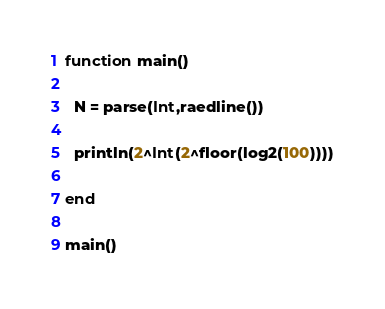Convert code to text. <code><loc_0><loc_0><loc_500><loc_500><_Julia_>function main()
  
  N = parse(Int,raedline())
  
  println(2^Int(2^floor(log2(100))))
  
end

main()</code> 